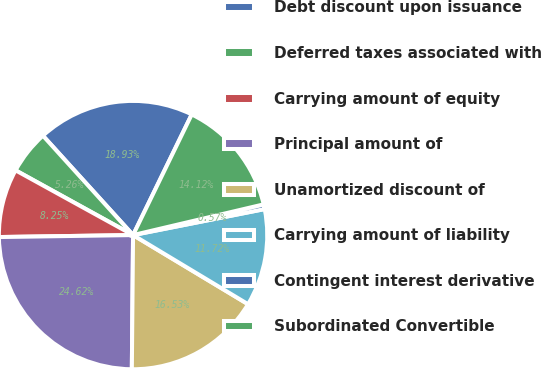<chart> <loc_0><loc_0><loc_500><loc_500><pie_chart><fcel>Debt discount upon issuance<fcel>Deferred taxes associated with<fcel>Carrying amount of equity<fcel>Principal amount of<fcel>Unamortized discount of<fcel>Carrying amount of liability<fcel>Contingent interest derivative<fcel>Subordinated Convertible<nl><fcel>18.93%<fcel>5.26%<fcel>8.25%<fcel>24.62%<fcel>16.53%<fcel>11.72%<fcel>0.57%<fcel>14.12%<nl></chart> 